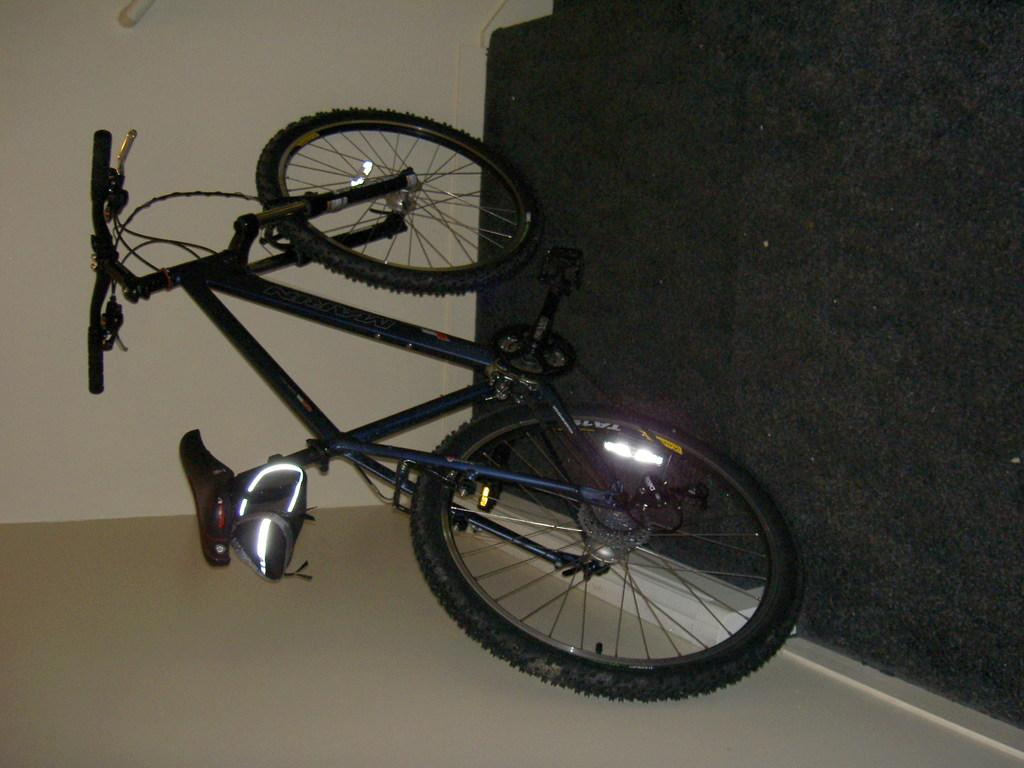What object is placed on the floor in the image? There is a bicycle placed on the floor. What can be seen in the background of the image? There is a staircase and a wall in the background of the image. What type of pain is the bicycle experiencing in the image? The bicycle is not experiencing any pain, as it is an inanimate object. 